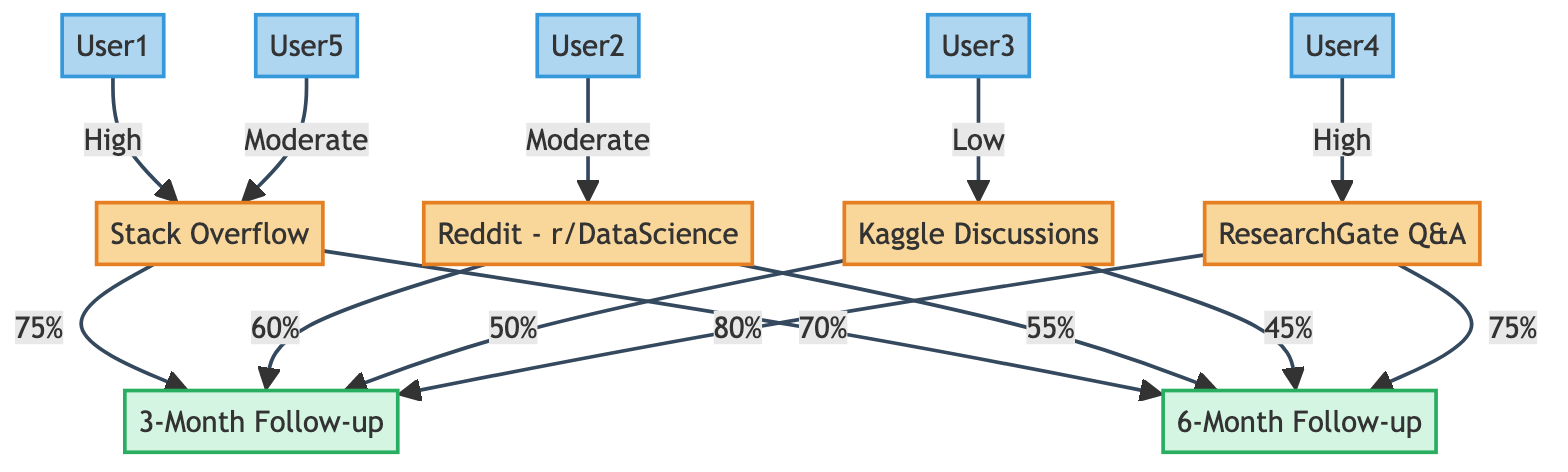How many forums are represented in the diagram? The diagram includes four forums: Stack Overflow, Reddit - r/DataScience, Kaggle Discussions, and ResearchGate Q&A. These can be counted from the nodes section labeled as "Forum."
Answer: 4 What is the knowledge retention rate from ResearchGate Q&A after 3 months? The edge connected from ResearchGate Q&A to the 3-Month Follow-up shows a knowledge retention rate of 80%. This value is stated directly on the edge in the diagram.
Answer: 80% Which user has high participation in more than one forum? User1 and User4 have high participation in Stack Overflow and ResearchGate Q&A, respectively. However, User1 is the only one who participates at high levels in multiple forums. This can be seen from the connections to the respective forums labeled with "High."
Answer: User1 What is the knowledge retention rate from Stack Overflow after 6 months? The edge connecting Stack Overflow to the 6-Month Follow-up indicates a knowledge retention rate of 70%. This rate is specifically indicated on the edge in the diagram.
Answer: 70% Which forum experienced the lowest knowledge retention rate at the 6-Month Follow-up? Upon examining the connections for the 6-Month Follow-up, Kaggle Discussions has the lowest retention rate at 45%. By comparing all edges leading to survey_2, it is clear that this is the minimum rate.
Answer: 45% What is the participation level of User3 in Kaggle Discussions? The diagram specifies User3's participation level as "Low" in the connection to Kaggle Discussions. This is clearly labeled in the edge description that links User3 and the forum.
Answer: Low How does the knowledge retention rate of Reddit - r/DataScience compare between the two follow-ups? After reviewing the edges connected to Reddit - r/DataScience, the retention rates are 60% for the 3-Month Follow-up and 55% for the 6-Month Follow-up. Therefore, it can be deduced that there is a decrease of 5% between these assessments.
Answer: Decrease of 5% Which forum has the highest overall knowledge retention rates across all assessments? Stack Overflow has a 75% retention rate at the 3-Month Follow-up and a 70% at the 6-Month, which totals to 145%. ResearchGate Q&A follows, with 80% and 75%, totaling 155%. Therefore, ResearchGate Q&A has the highest overall retention rate when aggregated.
Answer: ResearchGate Q&A What type of nodes are User1 and User4 categorized as? All the users in this diagram, including User1 and User4, are categorized as "User" type nodes. This is indicated in the type classifications of the nodes.
Answer: User 